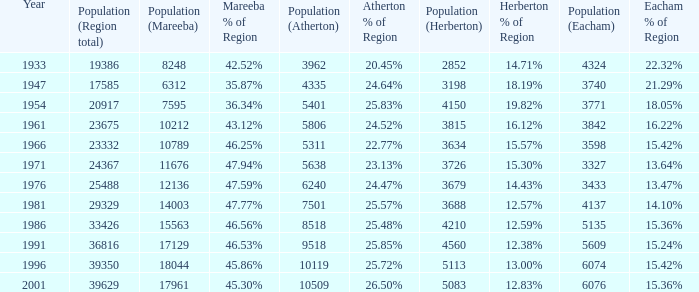What was the smallest population figure for Mareeba? 6312.0. 